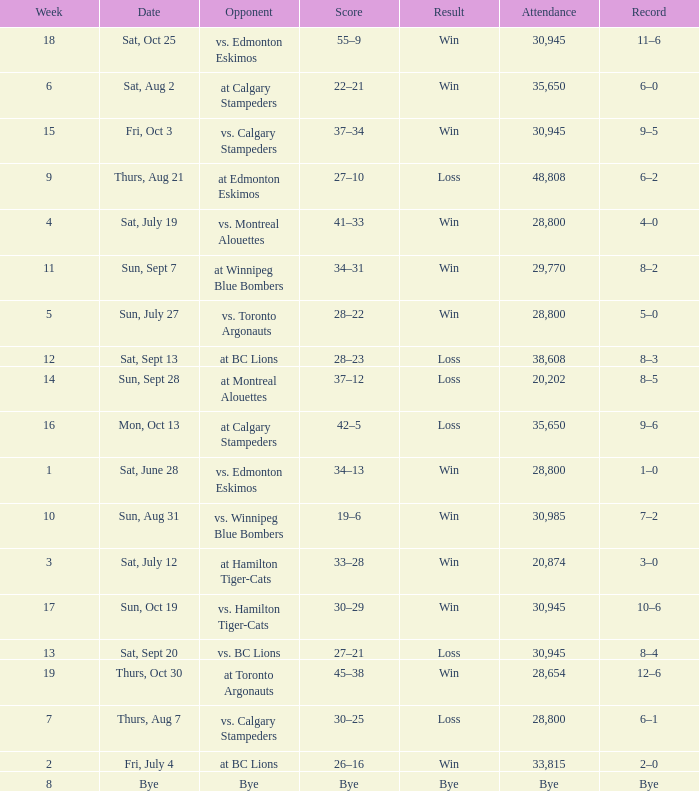Give me the full table as a dictionary. {'header': ['Week', 'Date', 'Opponent', 'Score', 'Result', 'Attendance', 'Record'], 'rows': [['18', 'Sat, Oct 25', 'vs. Edmonton Eskimos', '55–9', 'Win', '30,945', '11–6'], ['6', 'Sat, Aug 2', 'at Calgary Stampeders', '22–21', 'Win', '35,650', '6–0'], ['15', 'Fri, Oct 3', 'vs. Calgary Stampeders', '37–34', 'Win', '30,945', '9–5'], ['9', 'Thurs, Aug 21', 'at Edmonton Eskimos', '27–10', 'Loss', '48,808', '6–2'], ['4', 'Sat, July 19', 'vs. Montreal Alouettes', '41–33', 'Win', '28,800', '4–0'], ['11', 'Sun, Sept 7', 'at Winnipeg Blue Bombers', '34–31', 'Win', '29,770', '8–2'], ['5', 'Sun, July 27', 'vs. Toronto Argonauts', '28–22', 'Win', '28,800', '5–0'], ['12', 'Sat, Sept 13', 'at BC Lions', '28–23', 'Loss', '38,608', '8–3'], ['14', 'Sun, Sept 28', 'at Montreal Alouettes', '37–12', 'Loss', '20,202', '8–5'], ['16', 'Mon, Oct 13', 'at Calgary Stampeders', '42–5', 'Loss', '35,650', '9–6'], ['1', 'Sat, June 28', 'vs. Edmonton Eskimos', '34–13', 'Win', '28,800', '1–0'], ['10', 'Sun, Aug 31', 'vs. Winnipeg Blue Bombers', '19–6', 'Win', '30,985', '7–2'], ['3', 'Sat, July 12', 'at Hamilton Tiger-Cats', '33–28', 'Win', '20,874', '3–0'], ['17', 'Sun, Oct 19', 'vs. Hamilton Tiger-Cats', '30–29', 'Win', '30,945', '10–6'], ['13', 'Sat, Sept 20', 'vs. BC Lions', '27–21', 'Loss', '30,945', '8–4'], ['19', 'Thurs, Oct 30', 'at Toronto Argonauts', '45–38', 'Win', '28,654', '12–6'], ['7', 'Thurs, Aug 7', 'vs. Calgary Stampeders', '30–25', 'Loss', '28,800', '6–1'], ['2', 'Fri, July 4', 'at BC Lions', '26–16', 'Win', '33,815', '2–0'], ['8', 'Bye', 'Bye', 'Bye', 'Bye', 'Bye', 'Bye']]} What was the record the the match against vs. calgary stampeders before week 15? 6–1. 